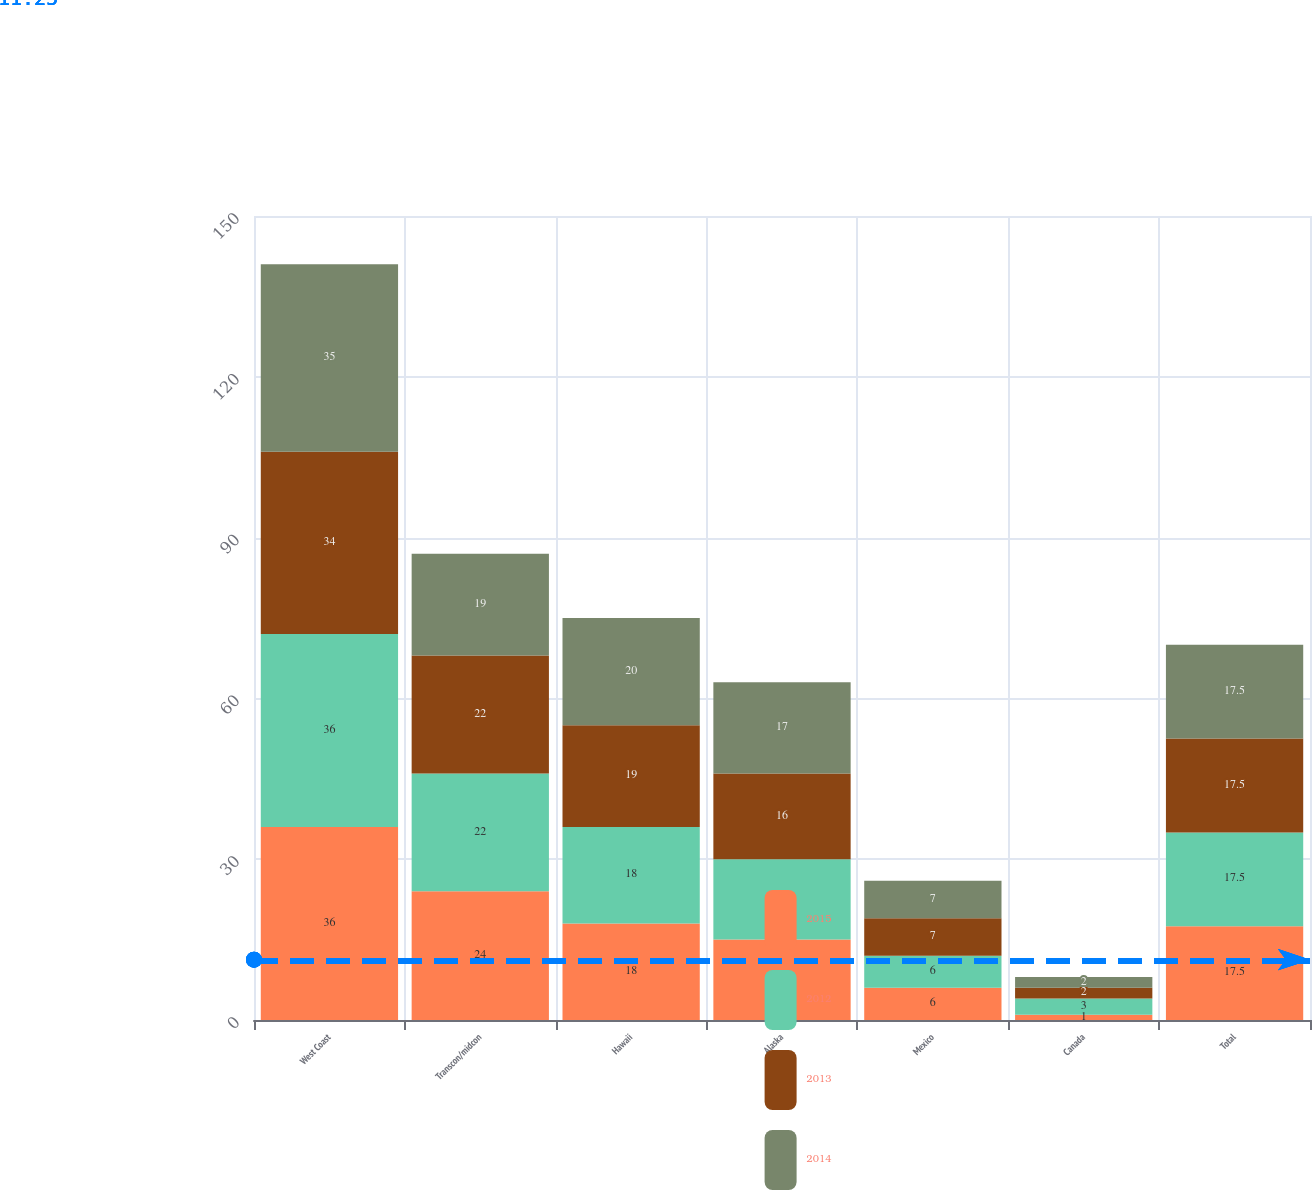Convert chart to OTSL. <chart><loc_0><loc_0><loc_500><loc_500><stacked_bar_chart><ecel><fcel>West Coast<fcel>Transcon/midcon<fcel>Hawaii<fcel>Alaska<fcel>Mexico<fcel>Canada<fcel>Total<nl><fcel>2015<fcel>36<fcel>24<fcel>18<fcel>15<fcel>6<fcel>1<fcel>17.5<nl><fcel>2012<fcel>36<fcel>22<fcel>18<fcel>15<fcel>6<fcel>3<fcel>17.5<nl><fcel>2013<fcel>34<fcel>22<fcel>19<fcel>16<fcel>7<fcel>2<fcel>17.5<nl><fcel>2014<fcel>35<fcel>19<fcel>20<fcel>17<fcel>7<fcel>2<fcel>17.5<nl></chart> 